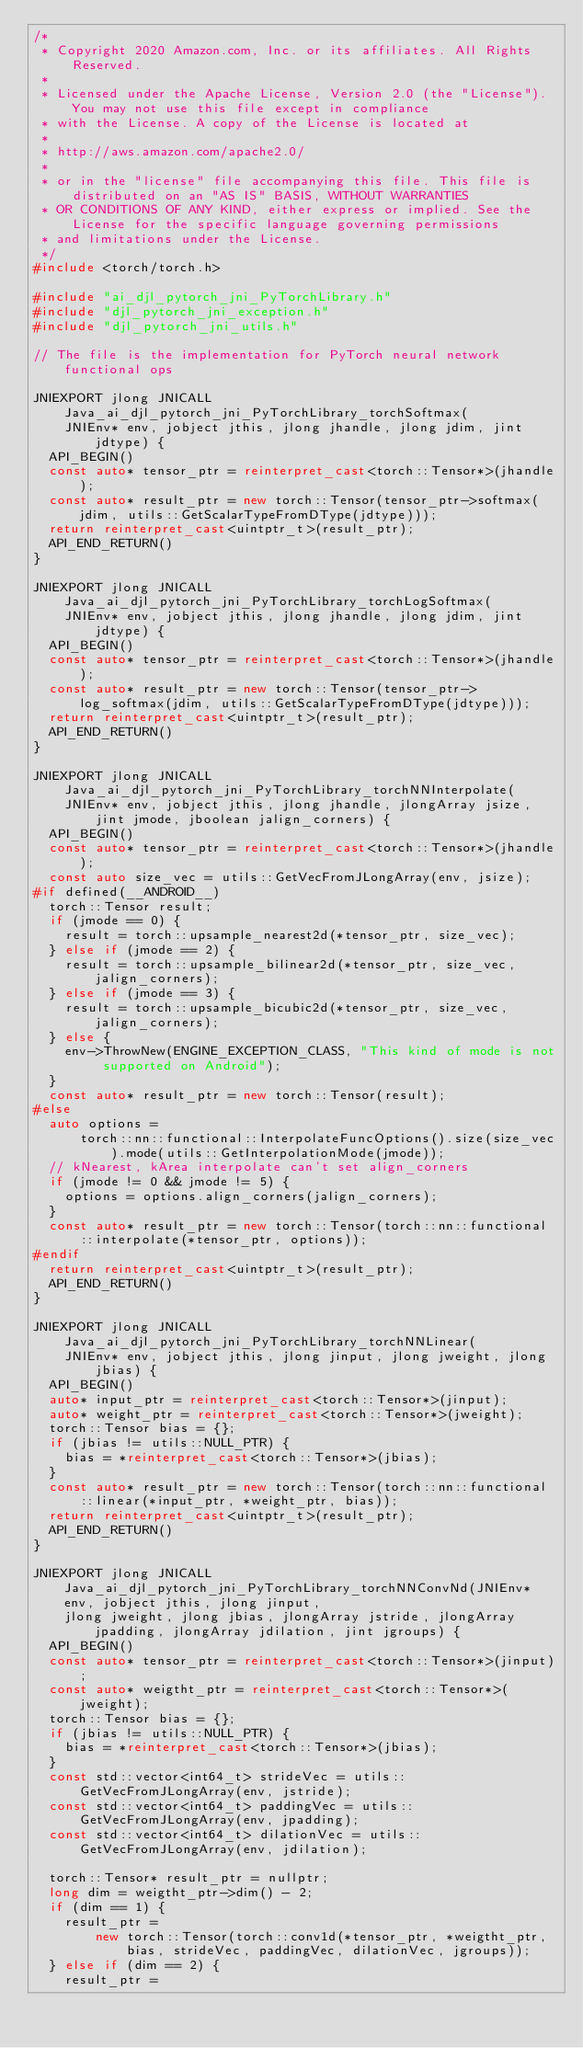<code> <loc_0><loc_0><loc_500><loc_500><_C++_>/*
 * Copyright 2020 Amazon.com, Inc. or its affiliates. All Rights Reserved.
 *
 * Licensed under the Apache License, Version 2.0 (the "License"). You may not use this file except in compliance
 * with the License. A copy of the License is located at
 *
 * http://aws.amazon.com/apache2.0/
 *
 * or in the "license" file accompanying this file. This file is distributed on an "AS IS" BASIS, WITHOUT WARRANTIES
 * OR CONDITIONS OF ANY KIND, either express or implied. See the License for the specific language governing permissions
 * and limitations under the License.
 */
#include <torch/torch.h>

#include "ai_djl_pytorch_jni_PyTorchLibrary.h"
#include "djl_pytorch_jni_exception.h"
#include "djl_pytorch_jni_utils.h"

// The file is the implementation for PyTorch neural network functional ops

JNIEXPORT jlong JNICALL Java_ai_djl_pytorch_jni_PyTorchLibrary_torchSoftmax(
    JNIEnv* env, jobject jthis, jlong jhandle, jlong jdim, jint jdtype) {
  API_BEGIN()
  const auto* tensor_ptr = reinterpret_cast<torch::Tensor*>(jhandle);
  const auto* result_ptr = new torch::Tensor(tensor_ptr->softmax(jdim, utils::GetScalarTypeFromDType(jdtype)));
  return reinterpret_cast<uintptr_t>(result_ptr);
  API_END_RETURN()
}

JNIEXPORT jlong JNICALL Java_ai_djl_pytorch_jni_PyTorchLibrary_torchLogSoftmax(
    JNIEnv* env, jobject jthis, jlong jhandle, jlong jdim, jint jdtype) {
  API_BEGIN()
  const auto* tensor_ptr = reinterpret_cast<torch::Tensor*>(jhandle);
  const auto* result_ptr = new torch::Tensor(tensor_ptr->log_softmax(jdim, utils::GetScalarTypeFromDType(jdtype)));
  return reinterpret_cast<uintptr_t>(result_ptr);
  API_END_RETURN()
}

JNIEXPORT jlong JNICALL Java_ai_djl_pytorch_jni_PyTorchLibrary_torchNNInterpolate(
    JNIEnv* env, jobject jthis, jlong jhandle, jlongArray jsize, jint jmode, jboolean jalign_corners) {
  API_BEGIN()
  const auto* tensor_ptr = reinterpret_cast<torch::Tensor*>(jhandle);
  const auto size_vec = utils::GetVecFromJLongArray(env, jsize);
#if defined(__ANDROID__)
  torch::Tensor result;
  if (jmode == 0) {
    result = torch::upsample_nearest2d(*tensor_ptr, size_vec);
  } else if (jmode == 2) {
    result = torch::upsample_bilinear2d(*tensor_ptr, size_vec, jalign_corners);
  } else if (jmode == 3) {
    result = torch::upsample_bicubic2d(*tensor_ptr, size_vec, jalign_corners);
  } else {
    env->ThrowNew(ENGINE_EXCEPTION_CLASS, "This kind of mode is not supported on Android");
  }
  const auto* result_ptr = new torch::Tensor(result);
#else
  auto options =
      torch::nn::functional::InterpolateFuncOptions().size(size_vec).mode(utils::GetInterpolationMode(jmode));
  // kNearest, kArea interpolate can't set align_corners
  if (jmode != 0 && jmode != 5) {
    options = options.align_corners(jalign_corners);
  }
  const auto* result_ptr = new torch::Tensor(torch::nn::functional::interpolate(*tensor_ptr, options));
#endif
  return reinterpret_cast<uintptr_t>(result_ptr);
  API_END_RETURN()
}

JNIEXPORT jlong JNICALL Java_ai_djl_pytorch_jni_PyTorchLibrary_torchNNLinear(
    JNIEnv* env, jobject jthis, jlong jinput, jlong jweight, jlong jbias) {
  API_BEGIN()
  auto* input_ptr = reinterpret_cast<torch::Tensor*>(jinput);
  auto* weight_ptr = reinterpret_cast<torch::Tensor*>(jweight);
  torch::Tensor bias = {};
  if (jbias != utils::NULL_PTR) {
    bias = *reinterpret_cast<torch::Tensor*>(jbias);
  }
  const auto* result_ptr = new torch::Tensor(torch::nn::functional::linear(*input_ptr, *weight_ptr, bias));
  return reinterpret_cast<uintptr_t>(result_ptr);
  API_END_RETURN()
}

JNIEXPORT jlong JNICALL Java_ai_djl_pytorch_jni_PyTorchLibrary_torchNNConvNd(JNIEnv* env, jobject jthis, jlong jinput,
    jlong jweight, jlong jbias, jlongArray jstride, jlongArray jpadding, jlongArray jdilation, jint jgroups) {
  API_BEGIN()
  const auto* tensor_ptr = reinterpret_cast<torch::Tensor*>(jinput);
  const auto* weigtht_ptr = reinterpret_cast<torch::Tensor*>(jweight);
  torch::Tensor bias = {};
  if (jbias != utils::NULL_PTR) {
    bias = *reinterpret_cast<torch::Tensor*>(jbias);
  }
  const std::vector<int64_t> strideVec = utils::GetVecFromJLongArray(env, jstride);
  const std::vector<int64_t> paddingVec = utils::GetVecFromJLongArray(env, jpadding);
  const std::vector<int64_t> dilationVec = utils::GetVecFromJLongArray(env, jdilation);

  torch::Tensor* result_ptr = nullptr;
  long dim = weigtht_ptr->dim() - 2;
  if (dim == 1) {
    result_ptr =
        new torch::Tensor(torch::conv1d(*tensor_ptr, *weigtht_ptr, bias, strideVec, paddingVec, dilationVec, jgroups));
  } else if (dim == 2) {
    result_ptr =</code> 